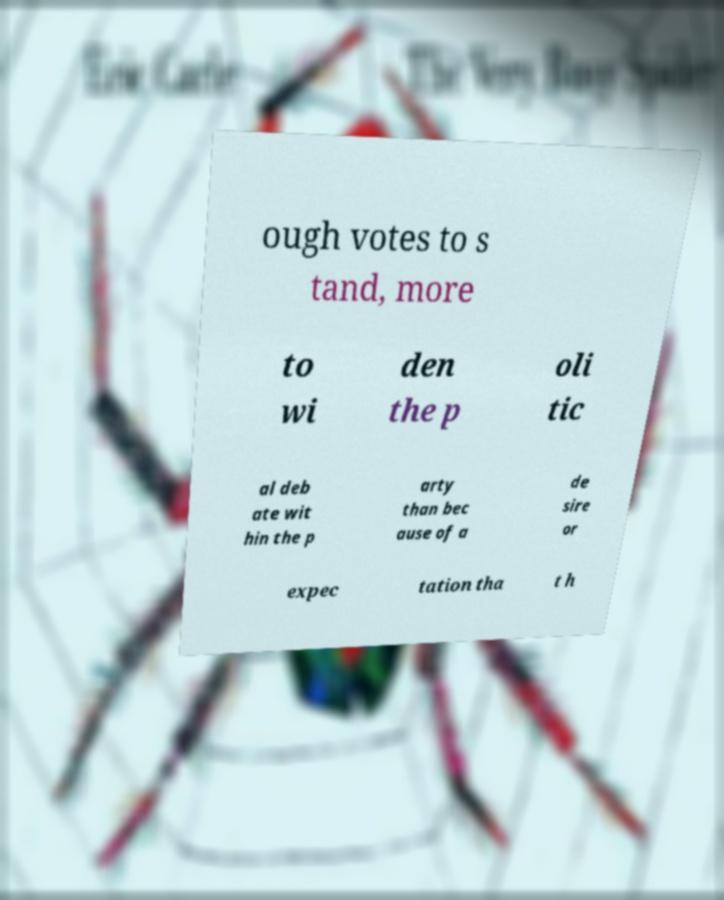What messages or text are displayed in this image? I need them in a readable, typed format. ough votes to s tand, more to wi den the p oli tic al deb ate wit hin the p arty than bec ause of a de sire or expec tation tha t h 